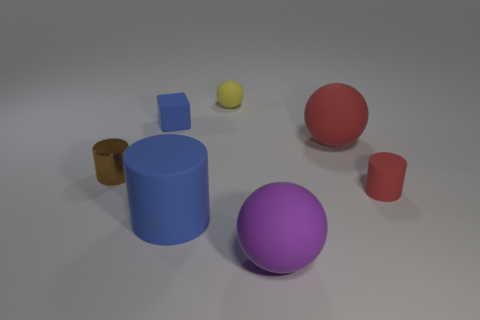Is there any other thing that has the same material as the brown object?
Provide a succinct answer. No. Do the block and the big cylinder have the same color?
Offer a terse response. Yes. What is the shape of the yellow rubber object that is the same size as the brown cylinder?
Your answer should be very brief. Sphere. What number of other things are the same color as the metal object?
Offer a terse response. 0. Is the shape of the blue matte object that is behind the brown cylinder the same as the thing behind the blue matte cube?
Your answer should be very brief. No. How many things are either rubber balls that are behind the small red rubber object or rubber objects that are on the right side of the blue matte cube?
Provide a succinct answer. 5. What number of other things are there of the same material as the yellow object
Provide a succinct answer. 5. Do the cylinder on the right side of the purple matte sphere and the tiny cube have the same material?
Your answer should be compact. Yes. Is the number of small matte cylinders that are behind the tiny cube greater than the number of cubes that are in front of the brown metallic thing?
Give a very brief answer. No. What number of objects are tiny matte objects that are to the left of the purple matte sphere or big rubber cylinders?
Provide a short and direct response. 3. 